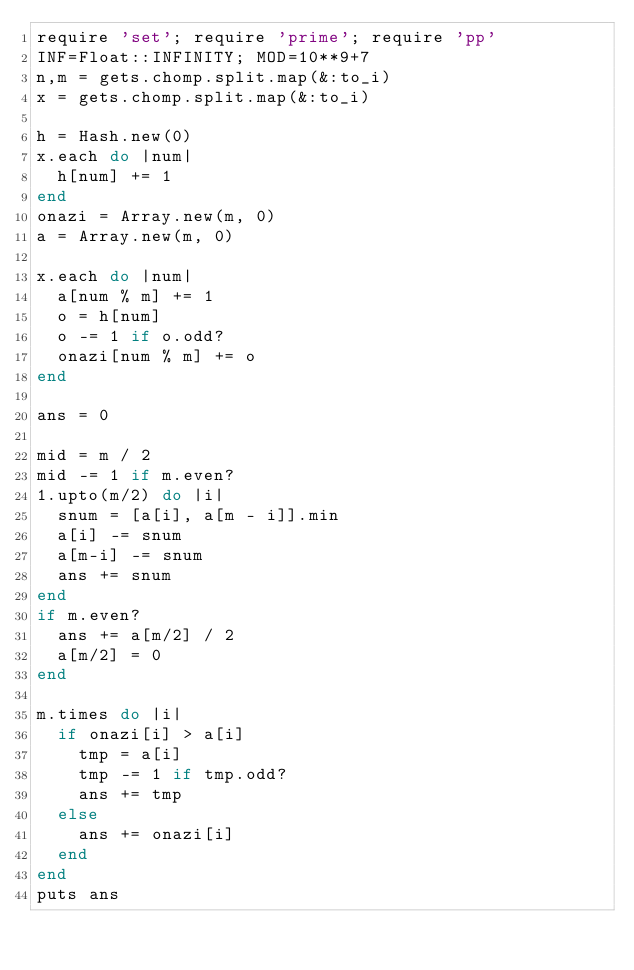Convert code to text. <code><loc_0><loc_0><loc_500><loc_500><_Ruby_>require 'set'; require 'prime'; require 'pp'
INF=Float::INFINITY; MOD=10**9+7
n,m = gets.chomp.split.map(&:to_i)
x = gets.chomp.split.map(&:to_i)

h = Hash.new(0)
x.each do |num|
  h[num] += 1
end
onazi = Array.new(m, 0)
a = Array.new(m, 0)

x.each do |num|
  a[num % m] += 1
  o = h[num]
  o -= 1 if o.odd?
  onazi[num % m] += o
end

ans = 0

mid = m / 2
mid -= 1 if m.even?
1.upto(m/2) do |i|
  snum = [a[i], a[m - i]].min
  a[i] -= snum
  a[m-i] -= snum
  ans += snum
end
if m.even?
  ans += a[m/2] / 2
  a[m/2] = 0
end

m.times do |i|
  if onazi[i] > a[i]
    tmp = a[i]
    tmp -= 1 if tmp.odd?
    ans += tmp
  else
    ans += onazi[i]
  end
end
puts ans
</code> 